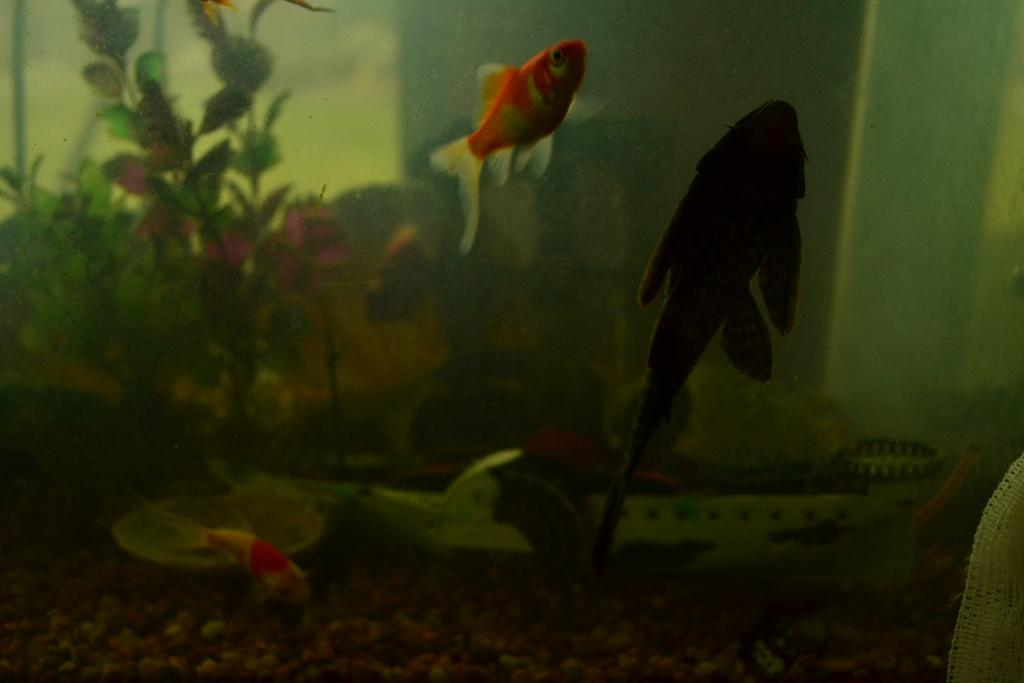What is the main subject of the picture? The main subject of the picture is an aquarium. What is inside the aquarium? The aquarium contains water, fishes, and plants. What is the limit of the team in the image? There is no team or limit mentioned in the image; it features an aquarium with water, fishes, and plants. What shape is the circle in the image? There is no circle present in the image. 